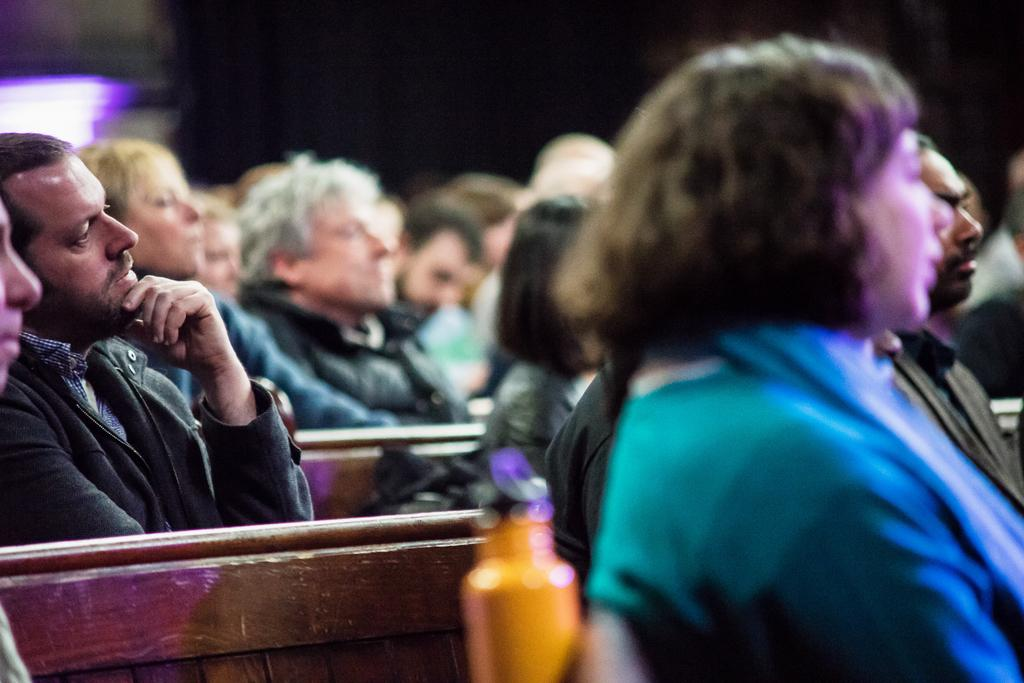What are the people in the image doing? The people in the image are sitting on benches. What might the people be listening to? The people are listening to something, but it is not specified in the image. Can you describe the person holding an object in the image? There is a person holding a yellow bottle in the image. How would you describe the lighting in the image? The background appears to be dark. How many women are walking past the cars in the image? There are no women or cars present in the image. 